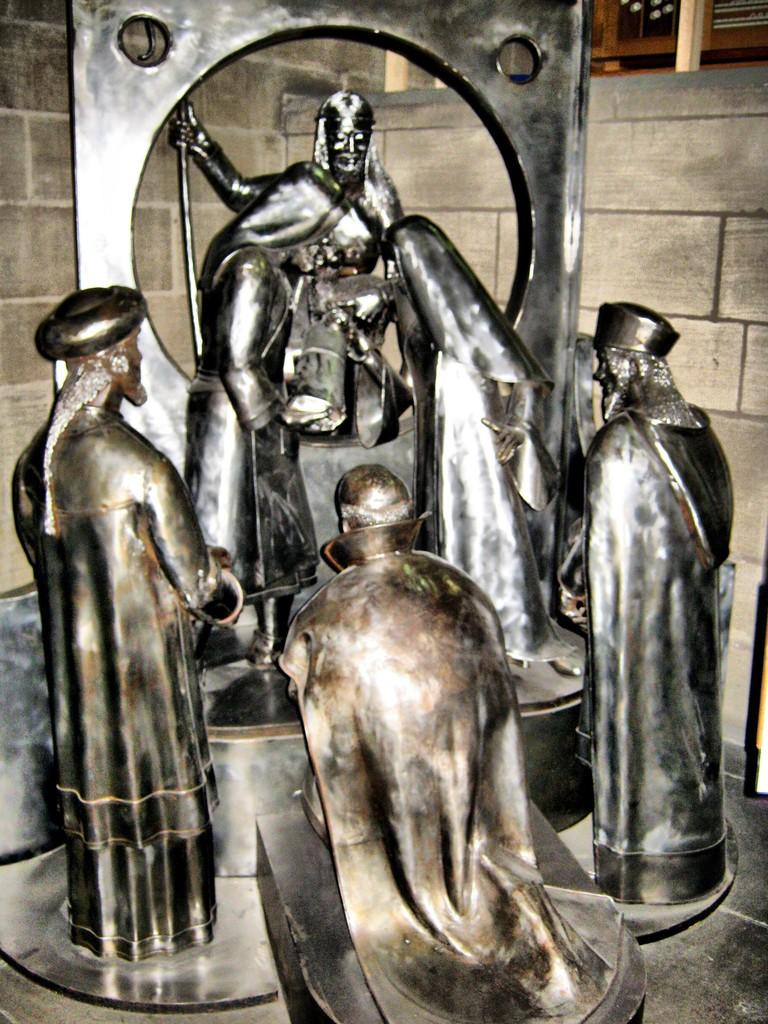What type of objects are featured in the image? There are metal sculptures in the image. What can be seen in the background of the image? There is a wall in the background of the image. What type of scent can be detected from the metal sculptures in the image? There is no indication of a scent in the image, as it features metal sculptures and a wall. 